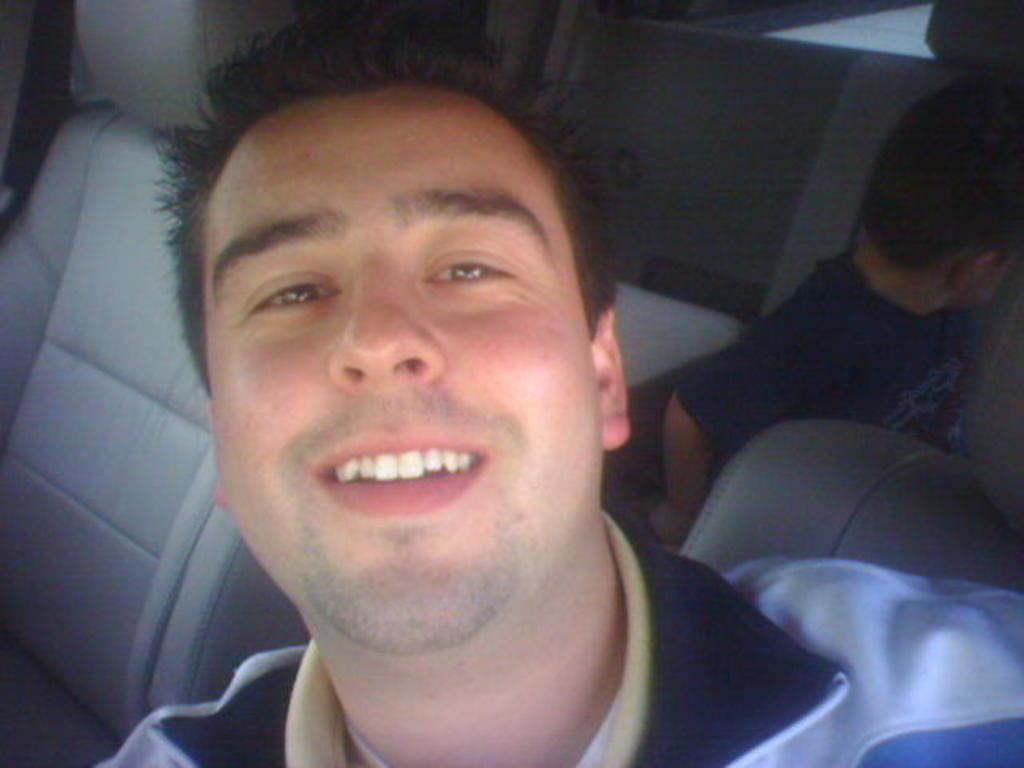Could you give a brief overview of what you see in this image? In this image, we can see a man and a kid in the vehicle. 